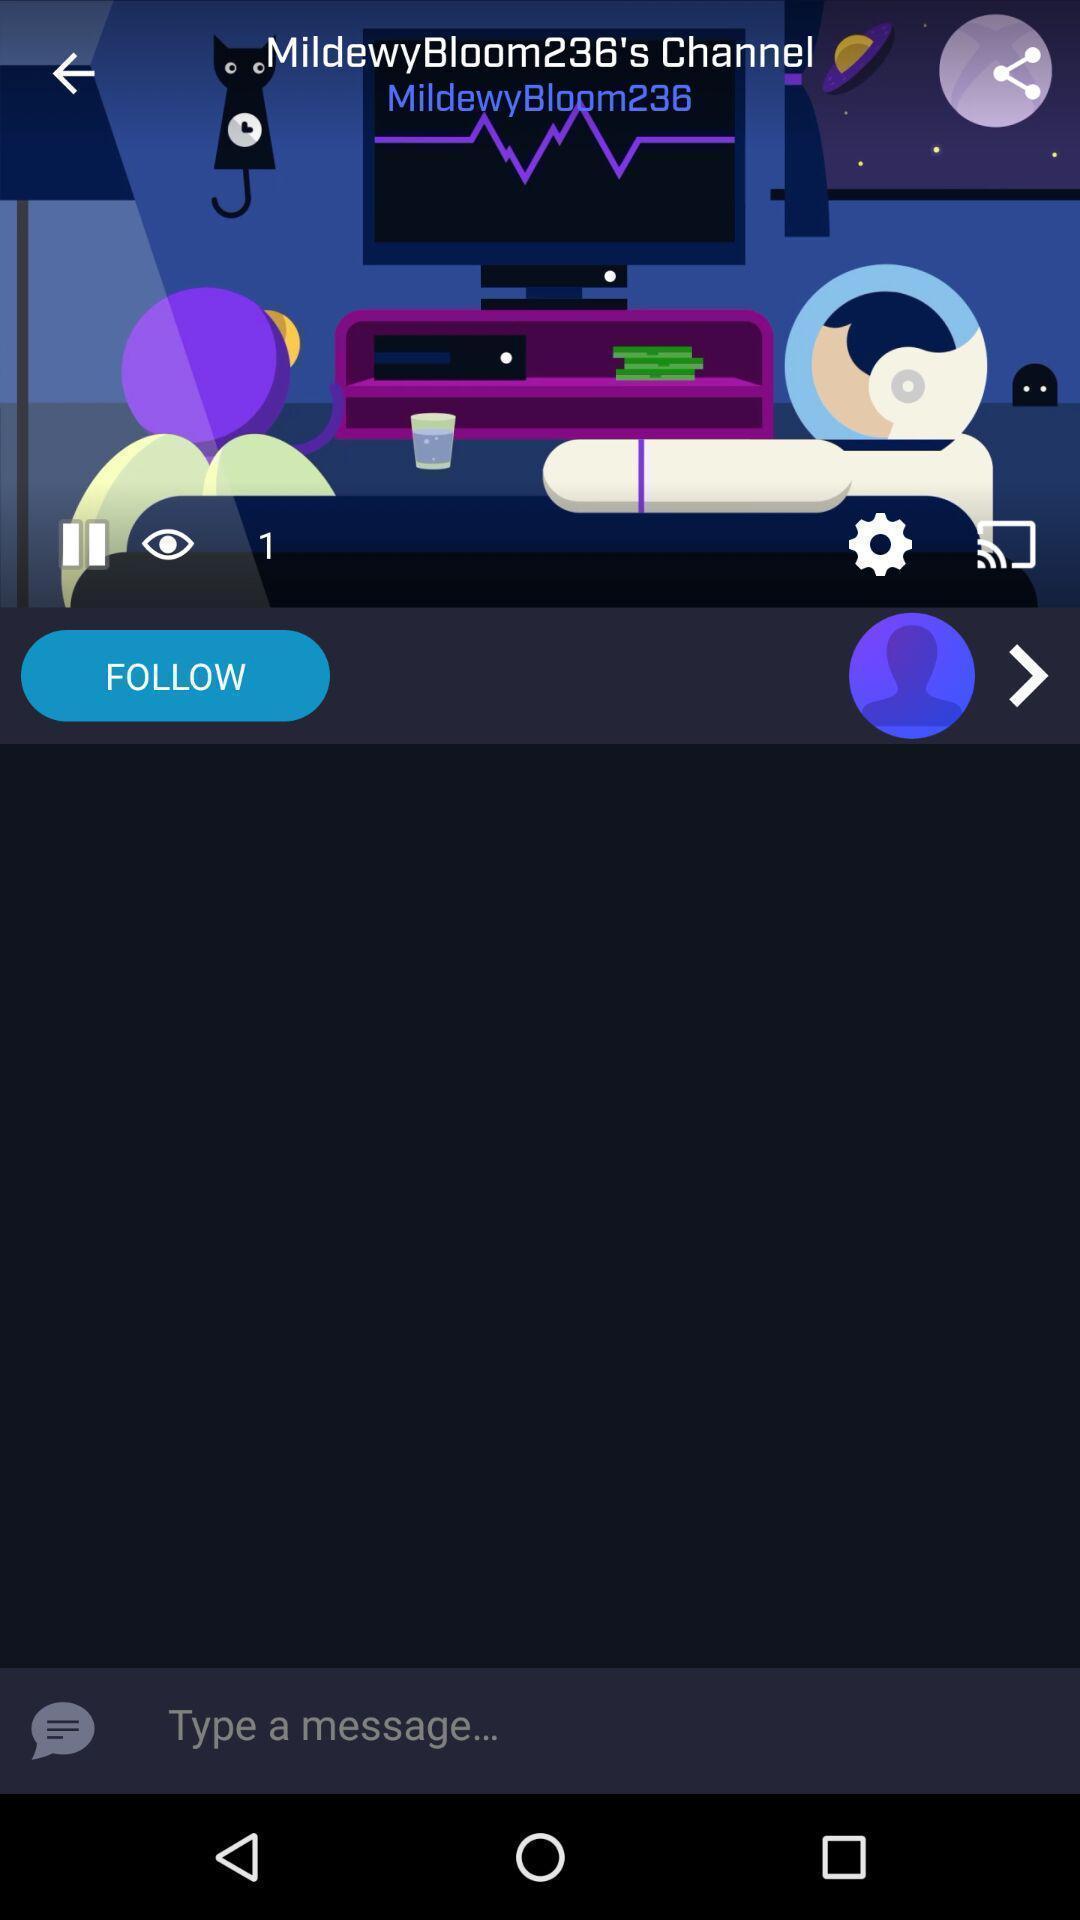Explain what's happening in this screen capture. Text page of messaging application. 